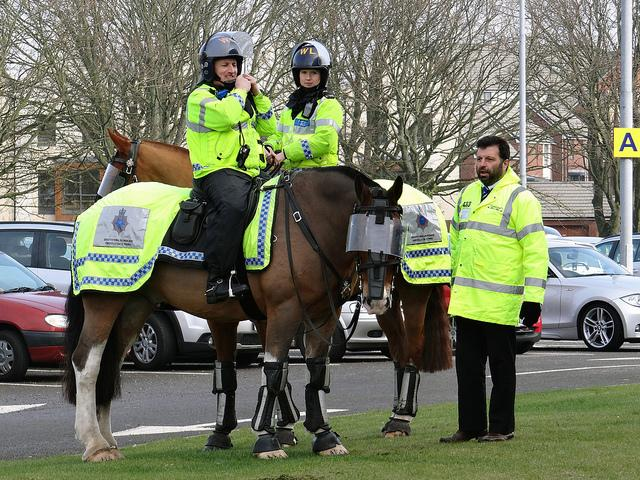What are they preparing for? work 